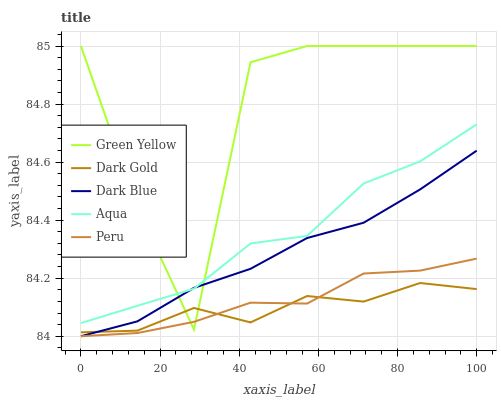Does Aqua have the minimum area under the curve?
Answer yes or no. No. Does Aqua have the maximum area under the curve?
Answer yes or no. No. Is Aqua the smoothest?
Answer yes or no. No. Is Aqua the roughest?
Answer yes or no. No. Does Green Yellow have the lowest value?
Answer yes or no. No. Does Aqua have the highest value?
Answer yes or no. No. Is Dark Gold less than Aqua?
Answer yes or no. Yes. Is Aqua greater than Peru?
Answer yes or no. Yes. Does Dark Gold intersect Aqua?
Answer yes or no. No. 